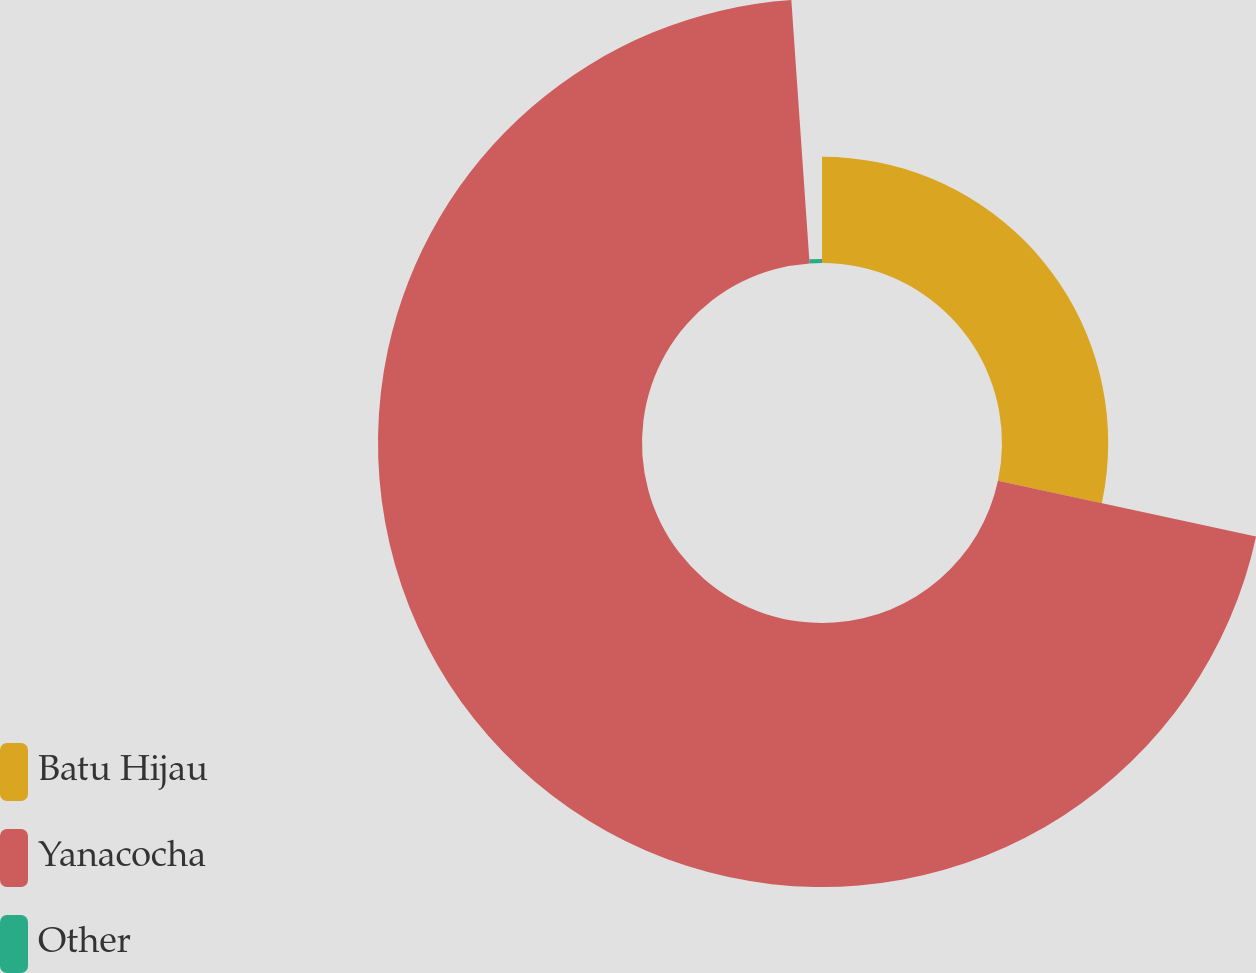Convert chart. <chart><loc_0><loc_0><loc_500><loc_500><pie_chart><fcel>Batu Hijau<fcel>Yanacocha<fcel>Other<nl><fcel>28.37%<fcel>70.52%<fcel>1.1%<nl></chart> 